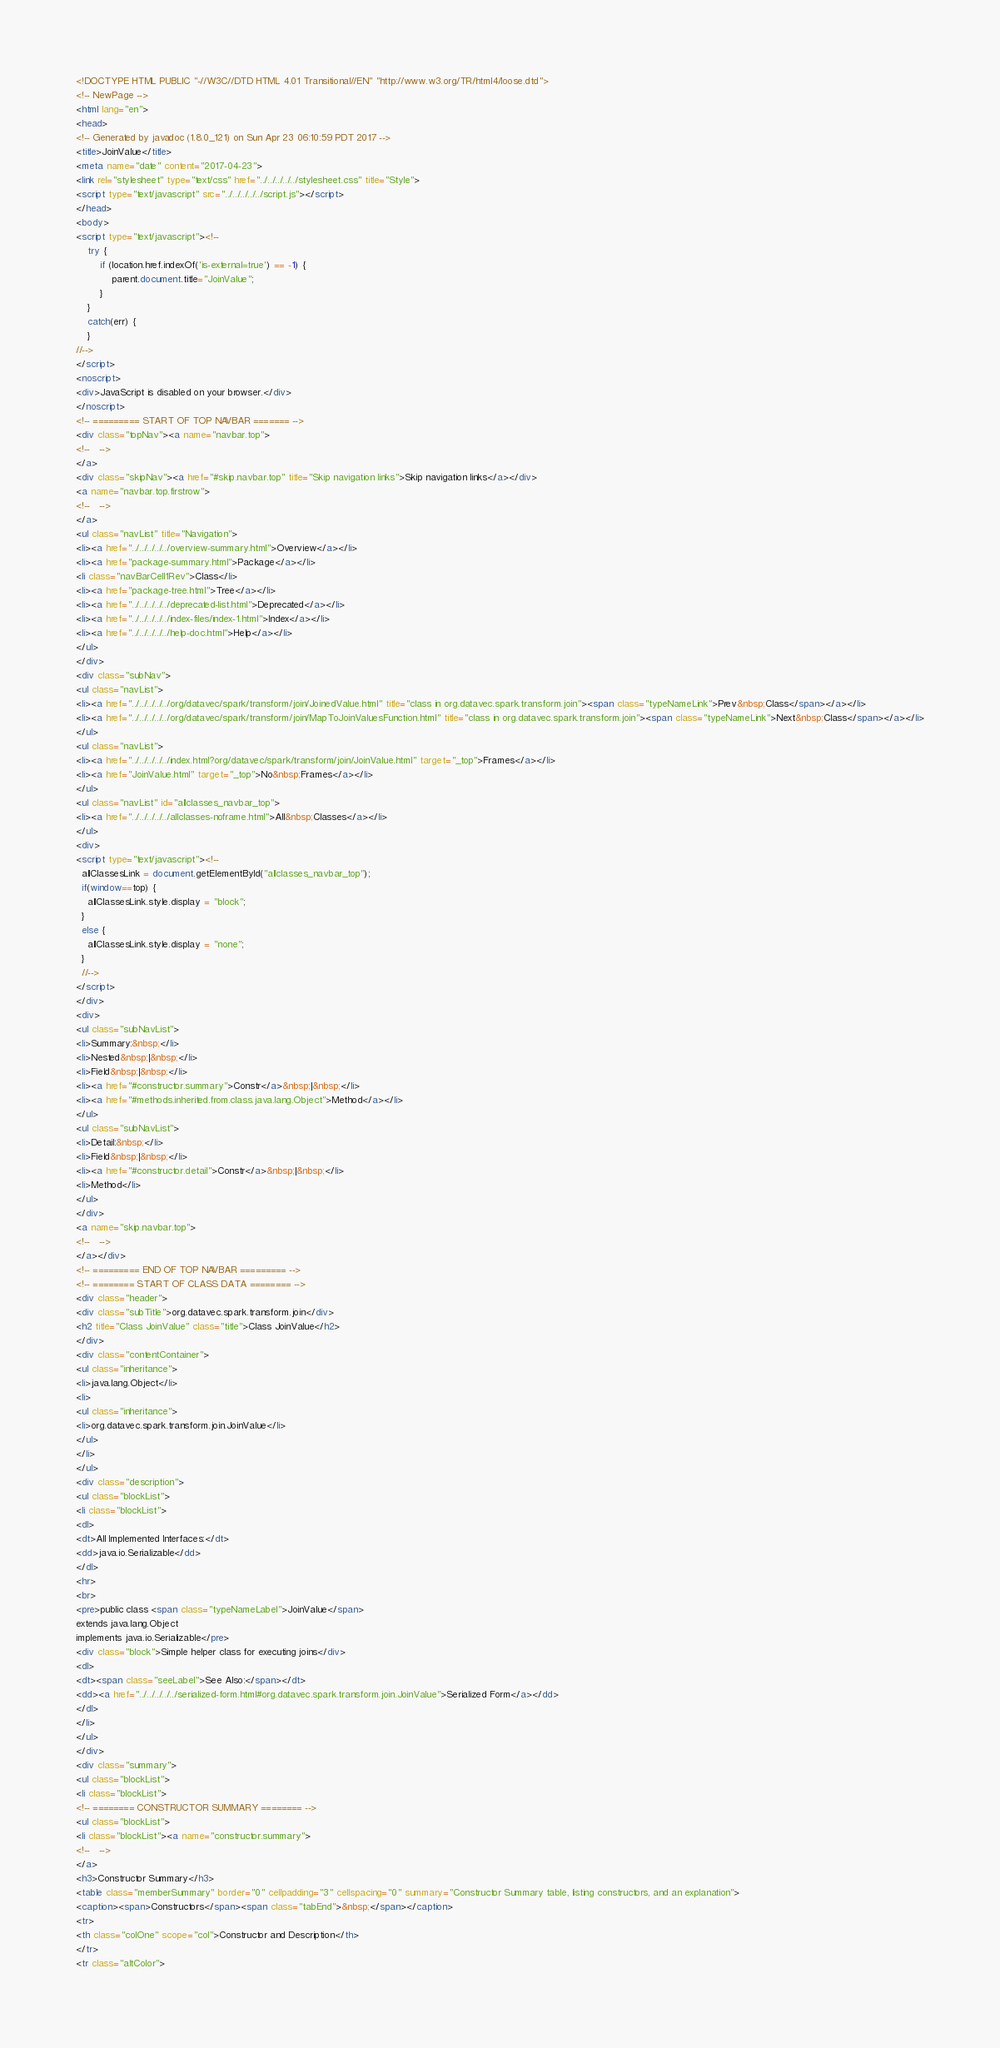<code> <loc_0><loc_0><loc_500><loc_500><_HTML_><!DOCTYPE HTML PUBLIC "-//W3C//DTD HTML 4.01 Transitional//EN" "http://www.w3.org/TR/html4/loose.dtd">
<!-- NewPage -->
<html lang="en">
<head>
<!-- Generated by javadoc (1.8.0_121) on Sun Apr 23 06:10:59 PDT 2017 -->
<title>JoinValue</title>
<meta name="date" content="2017-04-23">
<link rel="stylesheet" type="text/css" href="../../../../../stylesheet.css" title="Style">
<script type="text/javascript" src="../../../../../script.js"></script>
</head>
<body>
<script type="text/javascript"><!--
    try {
        if (location.href.indexOf('is-external=true') == -1) {
            parent.document.title="JoinValue";
        }
    }
    catch(err) {
    }
//-->
</script>
<noscript>
<div>JavaScript is disabled on your browser.</div>
</noscript>
<!-- ========= START OF TOP NAVBAR ======= -->
<div class="topNav"><a name="navbar.top">
<!--   -->
</a>
<div class="skipNav"><a href="#skip.navbar.top" title="Skip navigation links">Skip navigation links</a></div>
<a name="navbar.top.firstrow">
<!--   -->
</a>
<ul class="navList" title="Navigation">
<li><a href="../../../../../overview-summary.html">Overview</a></li>
<li><a href="package-summary.html">Package</a></li>
<li class="navBarCell1Rev">Class</li>
<li><a href="package-tree.html">Tree</a></li>
<li><a href="../../../../../deprecated-list.html">Deprecated</a></li>
<li><a href="../../../../../index-files/index-1.html">Index</a></li>
<li><a href="../../../../../help-doc.html">Help</a></li>
</ul>
</div>
<div class="subNav">
<ul class="navList">
<li><a href="../../../../../org/datavec/spark/transform/join/JoinedValue.html" title="class in org.datavec.spark.transform.join"><span class="typeNameLink">Prev&nbsp;Class</span></a></li>
<li><a href="../../../../../org/datavec/spark/transform/join/MapToJoinValuesFunction.html" title="class in org.datavec.spark.transform.join"><span class="typeNameLink">Next&nbsp;Class</span></a></li>
</ul>
<ul class="navList">
<li><a href="../../../../../index.html?org/datavec/spark/transform/join/JoinValue.html" target="_top">Frames</a></li>
<li><a href="JoinValue.html" target="_top">No&nbsp;Frames</a></li>
</ul>
<ul class="navList" id="allclasses_navbar_top">
<li><a href="../../../../../allclasses-noframe.html">All&nbsp;Classes</a></li>
</ul>
<div>
<script type="text/javascript"><!--
  allClassesLink = document.getElementById("allclasses_navbar_top");
  if(window==top) {
    allClassesLink.style.display = "block";
  }
  else {
    allClassesLink.style.display = "none";
  }
  //-->
</script>
</div>
<div>
<ul class="subNavList">
<li>Summary:&nbsp;</li>
<li>Nested&nbsp;|&nbsp;</li>
<li>Field&nbsp;|&nbsp;</li>
<li><a href="#constructor.summary">Constr</a>&nbsp;|&nbsp;</li>
<li><a href="#methods.inherited.from.class.java.lang.Object">Method</a></li>
</ul>
<ul class="subNavList">
<li>Detail:&nbsp;</li>
<li>Field&nbsp;|&nbsp;</li>
<li><a href="#constructor.detail">Constr</a>&nbsp;|&nbsp;</li>
<li>Method</li>
</ul>
</div>
<a name="skip.navbar.top">
<!--   -->
</a></div>
<!-- ========= END OF TOP NAVBAR ========= -->
<!-- ======== START OF CLASS DATA ======== -->
<div class="header">
<div class="subTitle">org.datavec.spark.transform.join</div>
<h2 title="Class JoinValue" class="title">Class JoinValue</h2>
</div>
<div class="contentContainer">
<ul class="inheritance">
<li>java.lang.Object</li>
<li>
<ul class="inheritance">
<li>org.datavec.spark.transform.join.JoinValue</li>
</ul>
</li>
</ul>
<div class="description">
<ul class="blockList">
<li class="blockList">
<dl>
<dt>All Implemented Interfaces:</dt>
<dd>java.io.Serializable</dd>
</dl>
<hr>
<br>
<pre>public class <span class="typeNameLabel">JoinValue</span>
extends java.lang.Object
implements java.io.Serializable</pre>
<div class="block">Simple helper class for executing joins</div>
<dl>
<dt><span class="seeLabel">See Also:</span></dt>
<dd><a href="../../../../../serialized-form.html#org.datavec.spark.transform.join.JoinValue">Serialized Form</a></dd>
</dl>
</li>
</ul>
</div>
<div class="summary">
<ul class="blockList">
<li class="blockList">
<!-- ======== CONSTRUCTOR SUMMARY ======== -->
<ul class="blockList">
<li class="blockList"><a name="constructor.summary">
<!--   -->
</a>
<h3>Constructor Summary</h3>
<table class="memberSummary" border="0" cellpadding="3" cellspacing="0" summary="Constructor Summary table, listing constructors, and an explanation">
<caption><span>Constructors</span><span class="tabEnd">&nbsp;</span></caption>
<tr>
<th class="colOne" scope="col">Constructor and Description</th>
</tr>
<tr class="altColor"></code> 